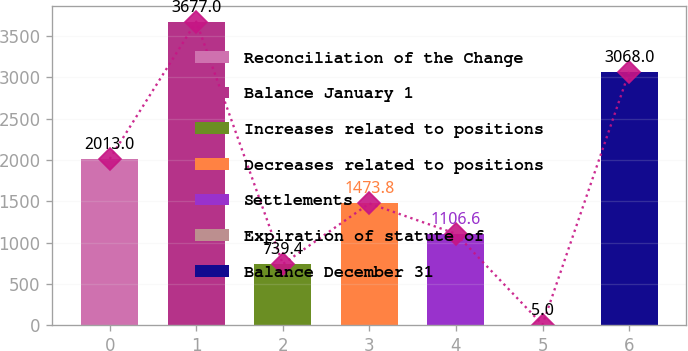Convert chart to OTSL. <chart><loc_0><loc_0><loc_500><loc_500><bar_chart><fcel>Reconciliation of the Change<fcel>Balance January 1<fcel>Increases related to positions<fcel>Decreases related to positions<fcel>Settlements<fcel>Expiration of statute of<fcel>Balance December 31<nl><fcel>2013<fcel>3677<fcel>739.4<fcel>1473.8<fcel>1106.6<fcel>5<fcel>3068<nl></chart> 